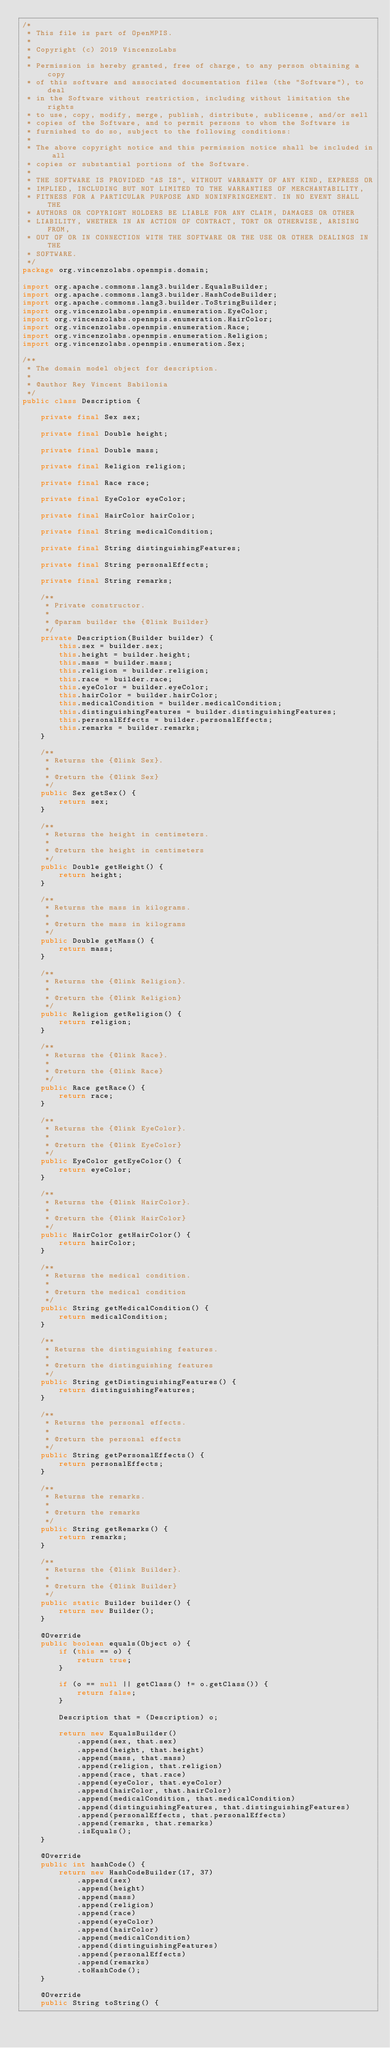Convert code to text. <code><loc_0><loc_0><loc_500><loc_500><_Java_>/*
 * This file is part of OpenMPIS.
 *
 * Copyright (c) 2019 VincenzoLabs
 *
 * Permission is hereby granted, free of charge, to any person obtaining a copy
 * of this software and associated documentation files (the "Software"), to deal
 * in the Software without restriction, including without limitation the rights
 * to use, copy, modify, merge, publish, distribute, sublicense, and/or sell
 * copies of the Software, and to permit persons to whom the Software is
 * furnished to do so, subject to the following conditions:
 *
 * The above copyright notice and this permission notice shall be included in all
 * copies or substantial portions of the Software.
 *
 * THE SOFTWARE IS PROVIDED "AS IS", WITHOUT WARRANTY OF ANY KIND, EXPRESS OR
 * IMPLIED, INCLUDING BUT NOT LIMITED TO THE WARRANTIES OF MERCHANTABILITY,
 * FITNESS FOR A PARTICULAR PURPOSE AND NONINFRINGEMENT. IN NO EVENT SHALL THE
 * AUTHORS OR COPYRIGHT HOLDERS BE LIABLE FOR ANY CLAIM, DAMAGES OR OTHER
 * LIABILITY, WHETHER IN AN ACTION OF CONTRACT, TORT OR OTHERWISE, ARISING FROM,
 * OUT OF OR IN CONNECTION WITH THE SOFTWARE OR THE USE OR OTHER DEALINGS IN THE
 * SOFTWARE.
 */
package org.vincenzolabs.openmpis.domain;

import org.apache.commons.lang3.builder.EqualsBuilder;
import org.apache.commons.lang3.builder.HashCodeBuilder;
import org.apache.commons.lang3.builder.ToStringBuilder;
import org.vincenzolabs.openmpis.enumeration.EyeColor;
import org.vincenzolabs.openmpis.enumeration.HairColor;
import org.vincenzolabs.openmpis.enumeration.Race;
import org.vincenzolabs.openmpis.enumeration.Religion;
import org.vincenzolabs.openmpis.enumeration.Sex;

/**
 * The domain model object for description.
 *
 * @author Rey Vincent Babilonia
 */
public class Description {

    private final Sex sex;

    private final Double height;

    private final Double mass;

    private final Religion religion;

    private final Race race;

    private final EyeColor eyeColor;

    private final HairColor hairColor;

    private final String medicalCondition;

    private final String distinguishingFeatures;

    private final String personalEffects;

    private final String remarks;

    /**
     * Private constructor.
     *
     * @param builder the {@link Builder}
     */
    private Description(Builder builder) {
        this.sex = builder.sex;
        this.height = builder.height;
        this.mass = builder.mass;
        this.religion = builder.religion;
        this.race = builder.race;
        this.eyeColor = builder.eyeColor;
        this.hairColor = builder.hairColor;
        this.medicalCondition = builder.medicalCondition;
        this.distinguishingFeatures = builder.distinguishingFeatures;
        this.personalEffects = builder.personalEffects;
        this.remarks = builder.remarks;
    }

    /**
     * Returns the {@link Sex}.
     *
     * @return the {@link Sex}
     */
    public Sex getSex() {
        return sex;
    }

    /**
     * Returns the height in centimeters.
     *
     * @return the height in centimeters
     */
    public Double getHeight() {
        return height;
    }

    /**
     * Returns the mass in kilograms.
     *
     * @return the mass in kilograms
     */
    public Double getMass() {
        return mass;
    }

    /**
     * Returns the {@link Religion}.
     *
     * @return the {@link Religion}
     */
    public Religion getReligion() {
        return religion;
    }

    /**
     * Returns the {@link Race}.
     *
     * @return the {@link Race}
     */
    public Race getRace() {
        return race;
    }

    /**
     * Returns the {@link EyeColor}.
     *
     * @return the {@link EyeColor}
     */
    public EyeColor getEyeColor() {
        return eyeColor;
    }

    /**
     * Returns the {@link HairColor}.
     *
     * @return the {@link HairColor}
     */
    public HairColor getHairColor() {
        return hairColor;
    }

    /**
     * Returns the medical condition.
     *
     * @return the medical condition
     */
    public String getMedicalCondition() {
        return medicalCondition;
    }

    /**
     * Returns the distinguishing features.
     *
     * @return the distinguishing features
     */
    public String getDistinguishingFeatures() {
        return distinguishingFeatures;
    }

    /**
     * Returns the personal effects.
     *
     * @return the personal effects
     */
    public String getPersonalEffects() {
        return personalEffects;
    }

    /**
     * Returns the remarks.
     *
     * @return the remarks
     */
    public String getRemarks() {
        return remarks;
    }

    /**
     * Returns the {@link Builder}.
     *
     * @return the {@link Builder}
     */
    public static Builder builder() {
        return new Builder();
    }

    @Override
    public boolean equals(Object o) {
        if (this == o) {
            return true;
        }

        if (o == null || getClass() != o.getClass()) {
            return false;
        }

        Description that = (Description) o;

        return new EqualsBuilder()
            .append(sex, that.sex)
            .append(height, that.height)
            .append(mass, that.mass)
            .append(religion, that.religion)
            .append(race, that.race)
            .append(eyeColor, that.eyeColor)
            .append(hairColor, that.hairColor)
            .append(medicalCondition, that.medicalCondition)
            .append(distinguishingFeatures, that.distinguishingFeatures)
            .append(personalEffects, that.personalEffects)
            .append(remarks, that.remarks)
            .isEquals();
    }

    @Override
    public int hashCode() {
        return new HashCodeBuilder(17, 37)
            .append(sex)
            .append(height)
            .append(mass)
            .append(religion)
            .append(race)
            .append(eyeColor)
            .append(hairColor)
            .append(medicalCondition)
            .append(distinguishingFeatures)
            .append(personalEffects)
            .append(remarks)
            .toHashCode();
    }

    @Override
    public String toString() {</code> 